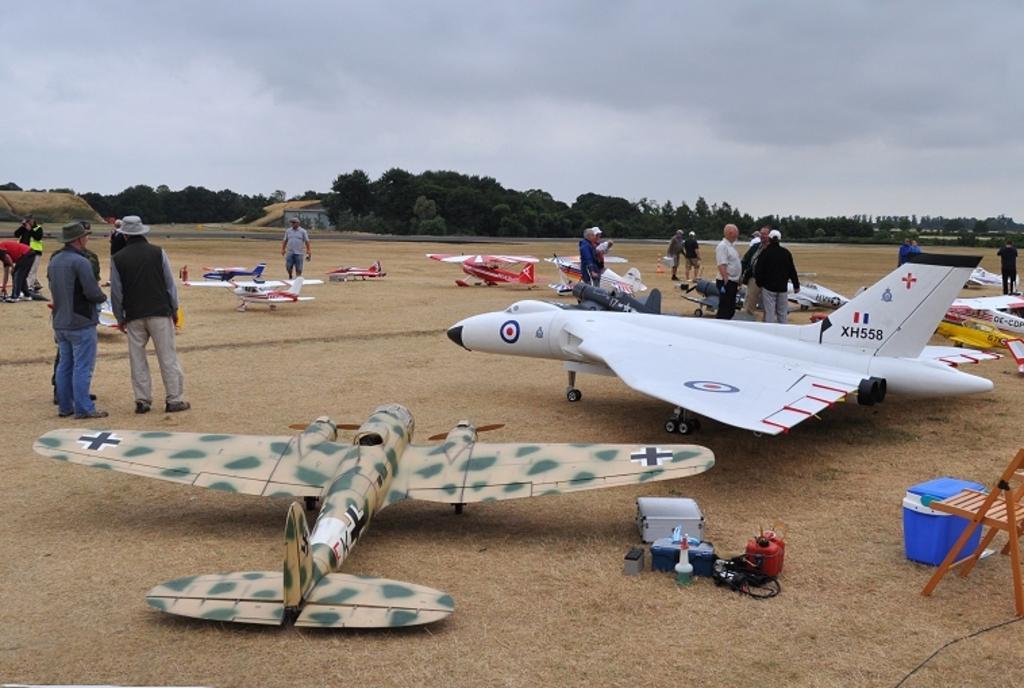Could you give a brief overview of what you see in this image? In this picture we can see few model aircraft and group of people, on the right side of the image we can see a chair, few boxes and other things, in the background we can find few trees and a building. 